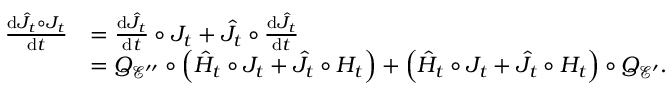Convert formula to latex. <formula><loc_0><loc_0><loc_500><loc_500>\begin{array} { r l } { \frac { d \hat { J } _ { t } \circ J _ { t } } { d t } } & { = \frac { d \hat { J } _ { t } } { d t } \circ J _ { t } + \hat { J } _ { t } \circ \frac { d \hat { J } _ { t } } { d t } } \\ & { = Q _ { \mathcal { E } ^ { \prime \prime } } \circ \left ( \hat { H } _ { t } \circ J _ { t } + \hat { J } _ { t } \circ H _ { t } \right ) + \left ( \hat { H } _ { t } \circ J _ { t } + \hat { J } _ { t } \circ H _ { t } \right ) \circ Q _ { \mathcal { E } ^ { \prime } } . } \end{array}</formula> 